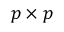Convert formula to latex. <formula><loc_0><loc_0><loc_500><loc_500>p \times p</formula> 